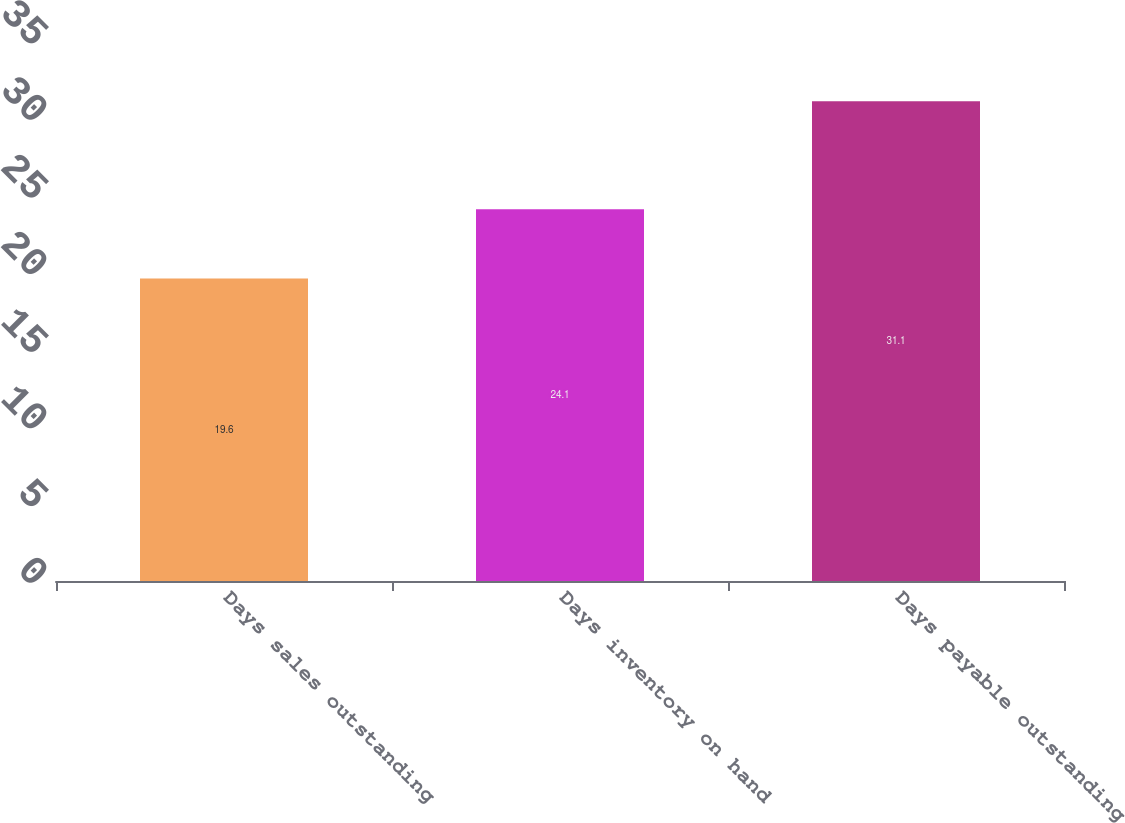<chart> <loc_0><loc_0><loc_500><loc_500><bar_chart><fcel>Days sales outstanding<fcel>Days inventory on hand<fcel>Days payable outstanding<nl><fcel>19.6<fcel>24.1<fcel>31.1<nl></chart> 